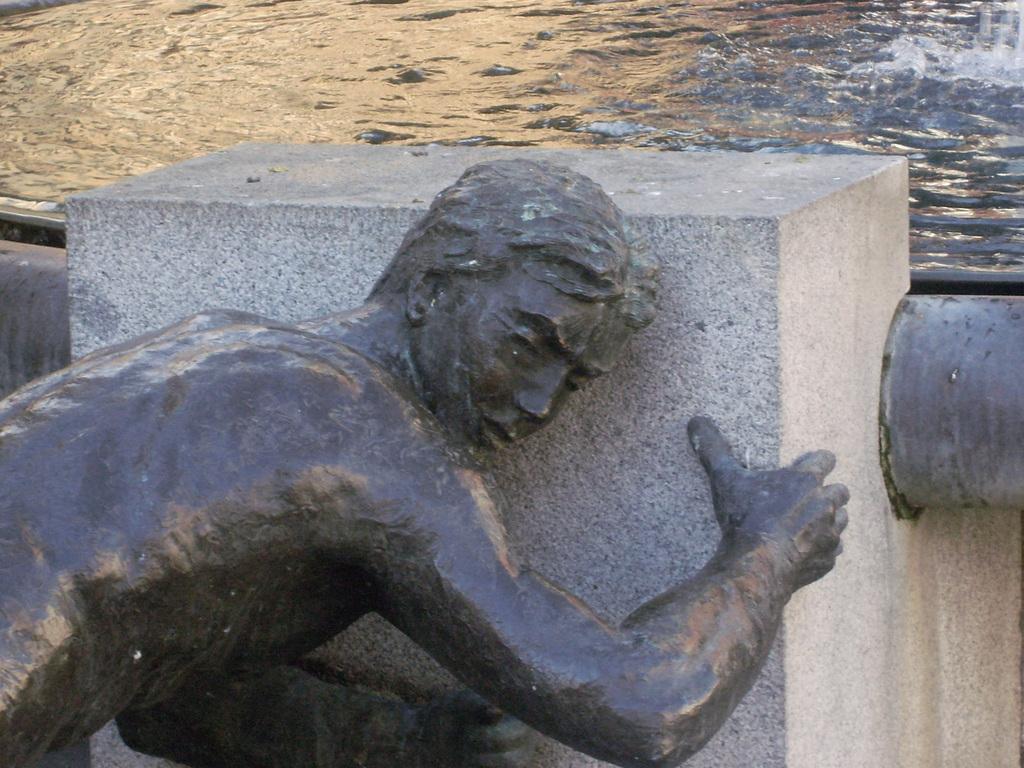In one or two sentences, can you explain what this image depicts? In this image we can see a statue, stone, and a pipe. In the background we can see water. 